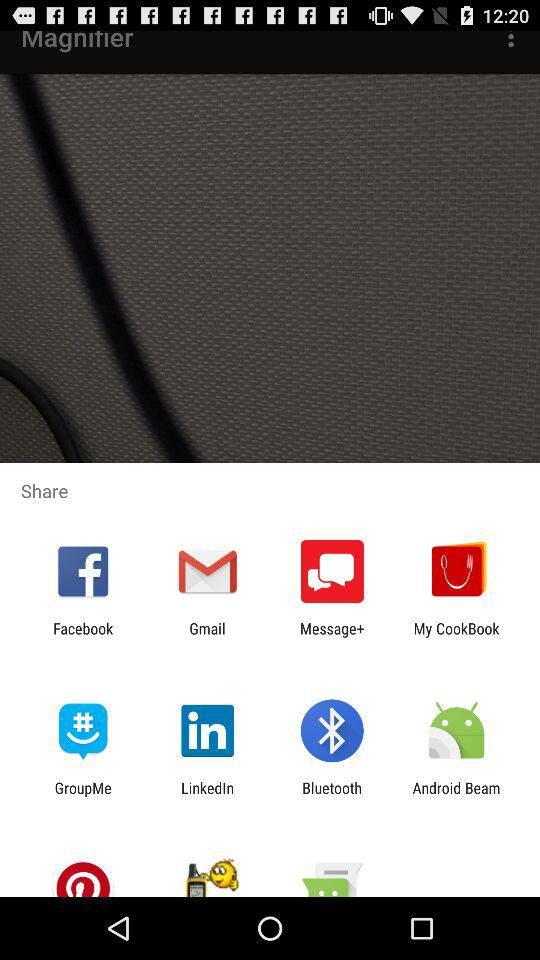What applications can be used to share? The applications that can be used to share are "Facebook", "Gmail", "Message+", "My CookBook", "GroupMe", "LinkedIn ", "Bluetooth" and "Android Beam". 